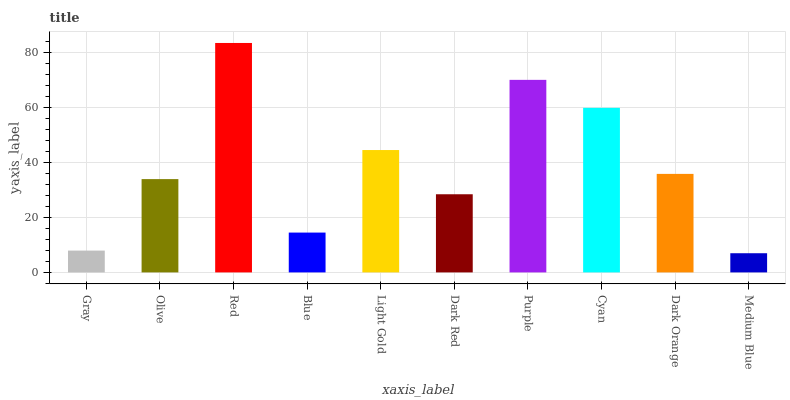Is Medium Blue the minimum?
Answer yes or no. Yes. Is Red the maximum?
Answer yes or no. Yes. Is Olive the minimum?
Answer yes or no. No. Is Olive the maximum?
Answer yes or no. No. Is Olive greater than Gray?
Answer yes or no. Yes. Is Gray less than Olive?
Answer yes or no. Yes. Is Gray greater than Olive?
Answer yes or no. No. Is Olive less than Gray?
Answer yes or no. No. Is Dark Orange the high median?
Answer yes or no. Yes. Is Olive the low median?
Answer yes or no. Yes. Is Light Gold the high median?
Answer yes or no. No. Is Cyan the low median?
Answer yes or no. No. 